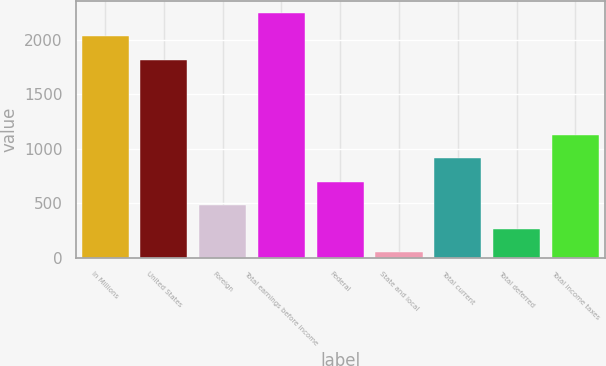<chart> <loc_0><loc_0><loc_500><loc_500><bar_chart><fcel>In Millions<fcel>United States<fcel>Foreign<fcel>Total earnings before income<fcel>Federal<fcel>State and local<fcel>Total current<fcel>Total deferred<fcel>Total income taxes<nl><fcel>2032.35<fcel>1816.5<fcel>483.7<fcel>2248.2<fcel>699.55<fcel>52<fcel>915.4<fcel>267.85<fcel>1131.25<nl></chart> 